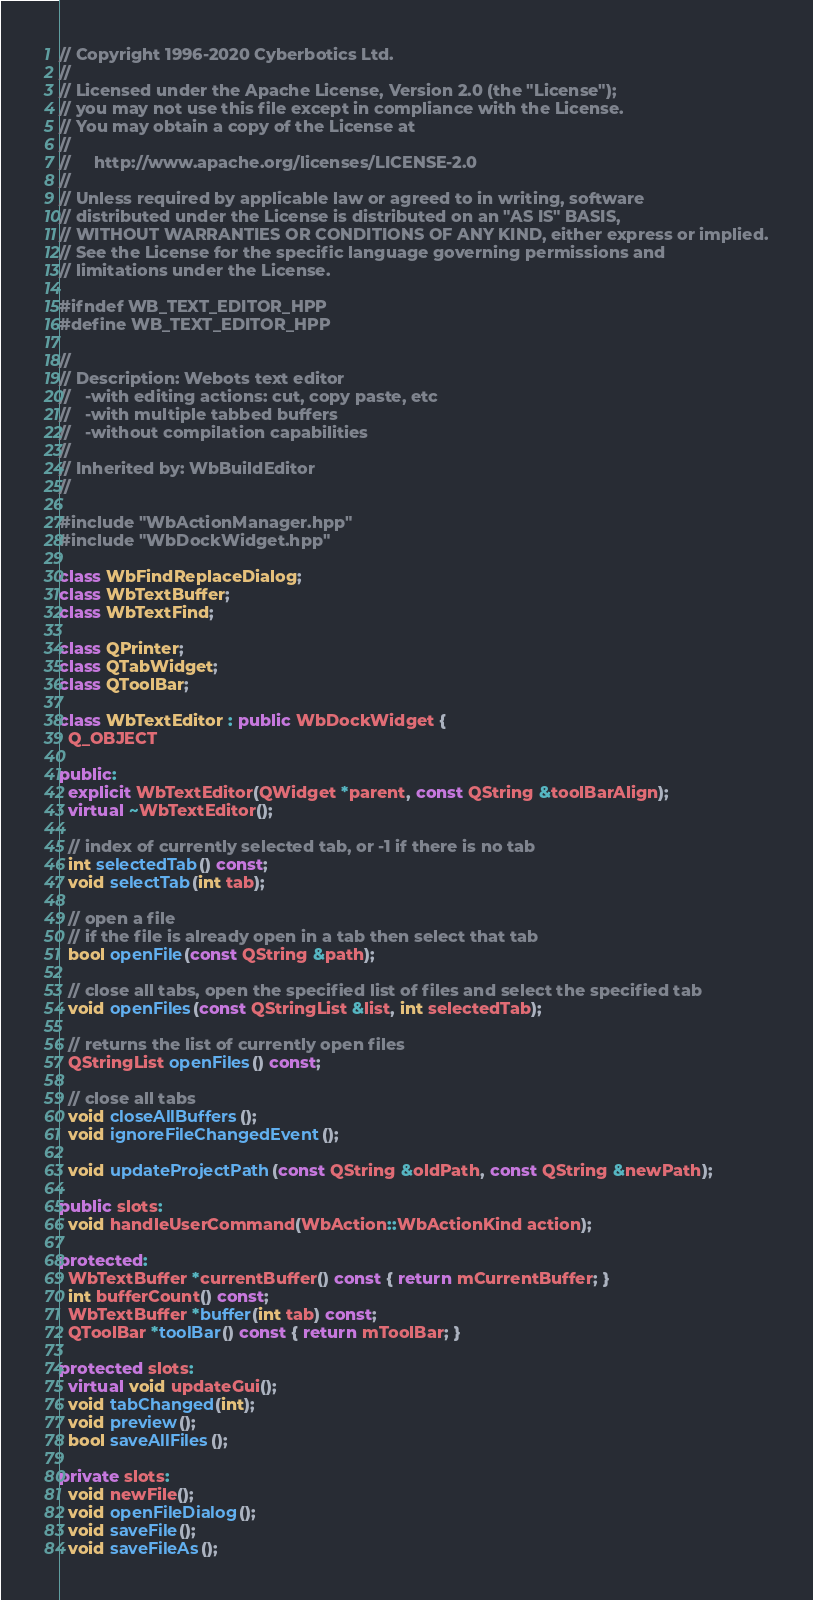<code> <loc_0><loc_0><loc_500><loc_500><_C++_>// Copyright 1996-2020 Cyberbotics Ltd.
//
// Licensed under the Apache License, Version 2.0 (the "License");
// you may not use this file except in compliance with the License.
// You may obtain a copy of the License at
//
//     http://www.apache.org/licenses/LICENSE-2.0
//
// Unless required by applicable law or agreed to in writing, software
// distributed under the License is distributed on an "AS IS" BASIS,
// WITHOUT WARRANTIES OR CONDITIONS OF ANY KIND, either express or implied.
// See the License for the specific language governing permissions and
// limitations under the License.

#ifndef WB_TEXT_EDITOR_HPP
#define WB_TEXT_EDITOR_HPP

//
// Description: Webots text editor
//   -with editing actions: cut, copy paste, etc
//   -with multiple tabbed buffers
//   -without compilation capabilities
//
// Inherited by: WbBuildEditor
//

#include "WbActionManager.hpp"
#include "WbDockWidget.hpp"

class WbFindReplaceDialog;
class WbTextBuffer;
class WbTextFind;

class QPrinter;
class QTabWidget;
class QToolBar;

class WbTextEditor : public WbDockWidget {
  Q_OBJECT

public:
  explicit WbTextEditor(QWidget *parent, const QString &toolBarAlign);
  virtual ~WbTextEditor();

  // index of currently selected tab, or -1 if there is no tab
  int selectedTab() const;
  void selectTab(int tab);

  // open a file
  // if the file is already open in a tab then select that tab
  bool openFile(const QString &path);

  // close all tabs, open the specified list of files and select the specified tab
  void openFiles(const QStringList &list, int selectedTab);

  // returns the list of currently open files
  QStringList openFiles() const;

  // close all tabs
  void closeAllBuffers();
  void ignoreFileChangedEvent();

  void updateProjectPath(const QString &oldPath, const QString &newPath);

public slots:
  void handleUserCommand(WbAction::WbActionKind action);

protected:
  WbTextBuffer *currentBuffer() const { return mCurrentBuffer; }
  int bufferCount() const;
  WbTextBuffer *buffer(int tab) const;
  QToolBar *toolBar() const { return mToolBar; }

protected slots:
  virtual void updateGui();
  void tabChanged(int);
  void preview();
  bool saveAllFiles();

private slots:
  void newFile();
  void openFileDialog();
  void saveFile();
  void saveFileAs();</code> 